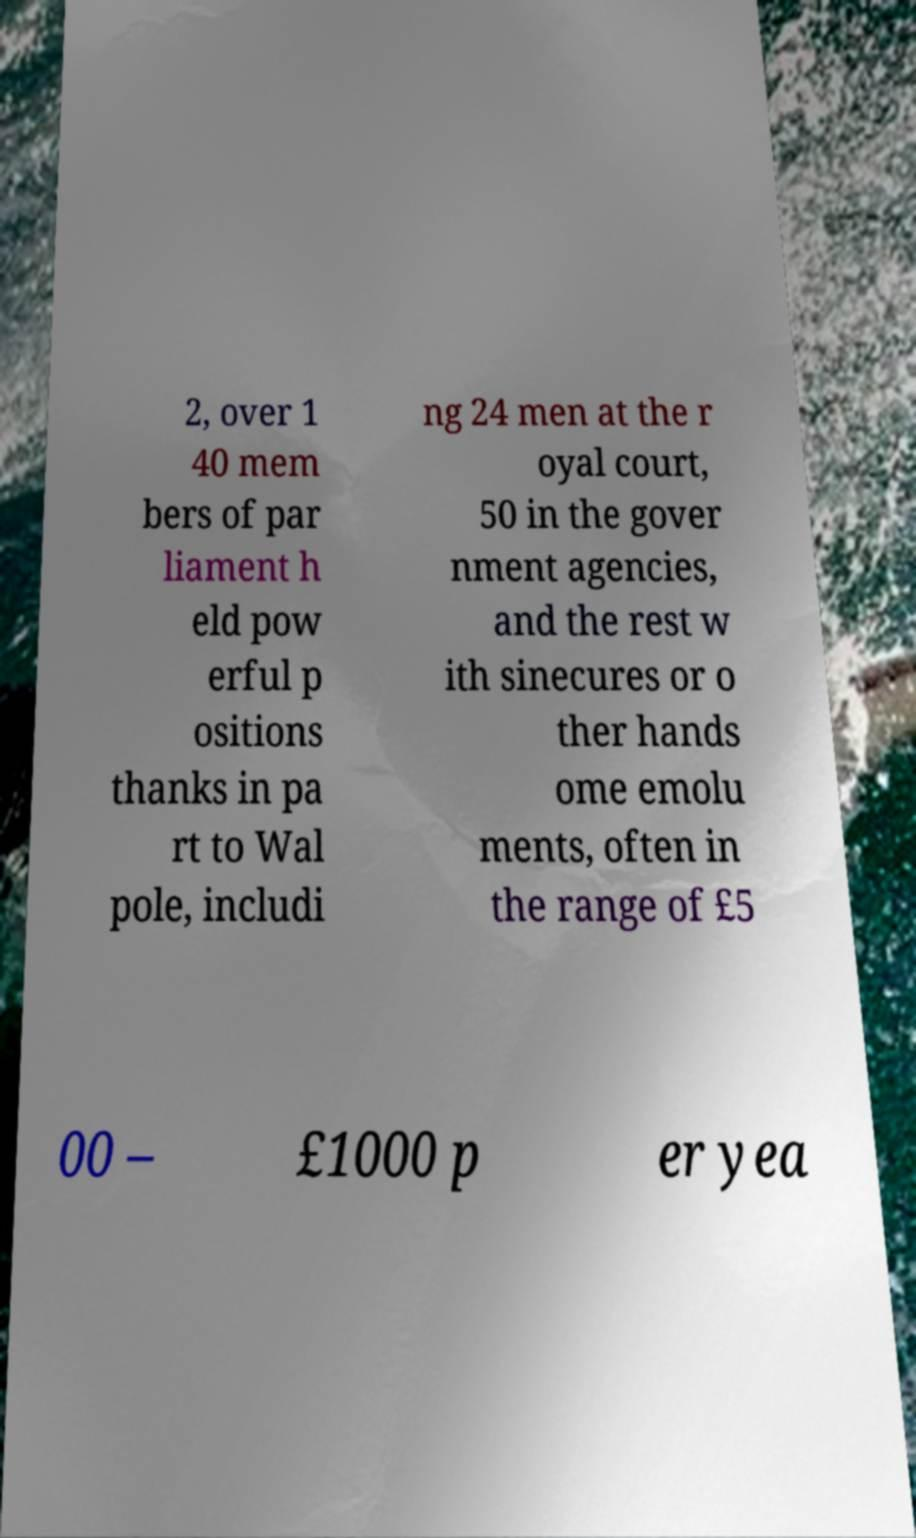Can you accurately transcribe the text from the provided image for me? 2, over 1 40 mem bers of par liament h eld pow erful p ositions thanks in pa rt to Wal pole, includi ng 24 men at the r oyal court, 50 in the gover nment agencies, and the rest w ith sinecures or o ther hands ome emolu ments, often in the range of £5 00 – £1000 p er yea 